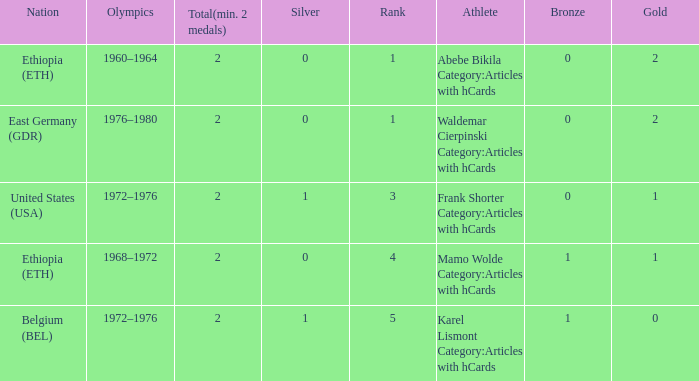What is the least amount of total medals won? 2.0. 